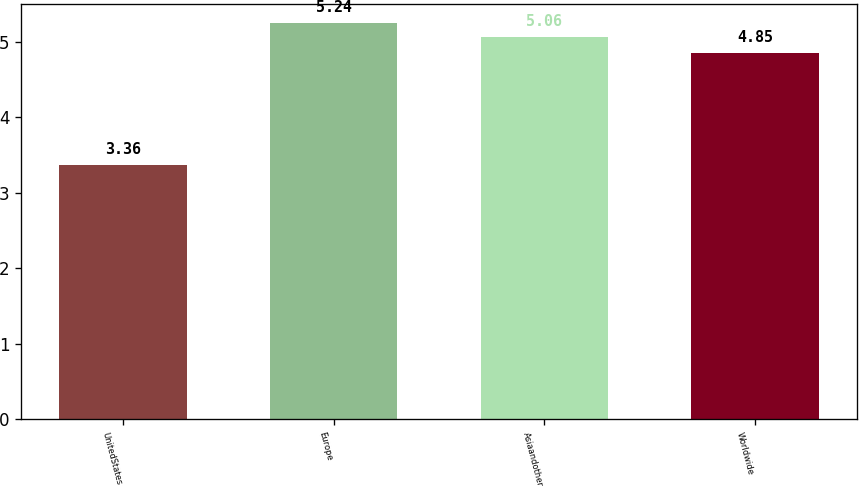Convert chart to OTSL. <chart><loc_0><loc_0><loc_500><loc_500><bar_chart><fcel>UnitedStates<fcel>Europe<fcel>Asiaandother<fcel>Worldwide<nl><fcel>3.36<fcel>5.24<fcel>5.06<fcel>4.85<nl></chart> 